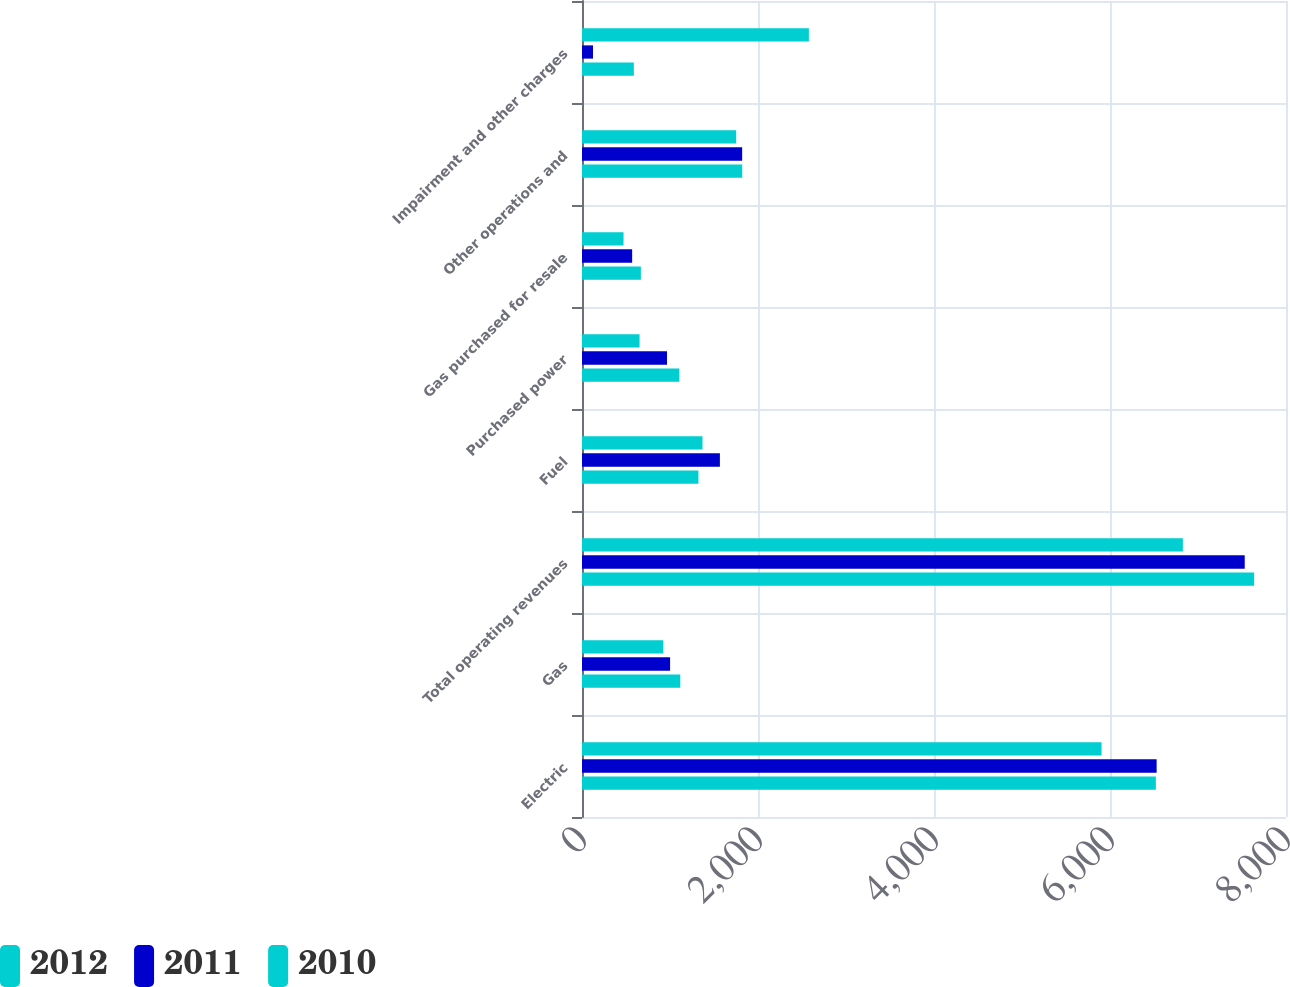Convert chart. <chart><loc_0><loc_0><loc_500><loc_500><stacked_bar_chart><ecel><fcel>Electric<fcel>Gas<fcel>Total operating revenues<fcel>Fuel<fcel>Purchased power<fcel>Gas purchased for resale<fcel>Other operations and<fcel>Impairment and other charges<nl><fcel>2012<fcel>5904<fcel>924<fcel>6828<fcel>1369<fcel>654<fcel>472<fcel>1752<fcel>2578<nl><fcel>2011<fcel>6530<fcel>1001<fcel>7531<fcel>1567<fcel>966<fcel>570<fcel>1820<fcel>125<nl><fcel>2010<fcel>6521<fcel>1117<fcel>7638<fcel>1323<fcel>1106<fcel>669<fcel>1821<fcel>589<nl></chart> 